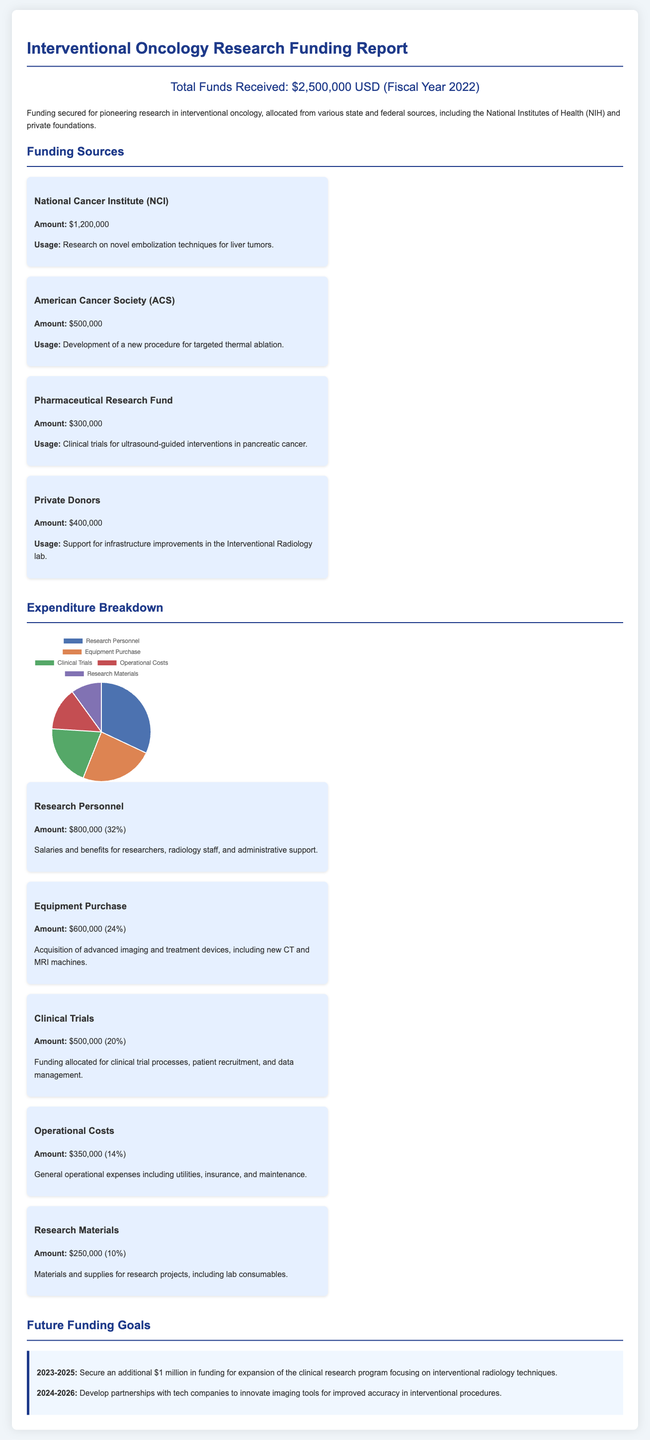What is the total funds received? The total funds received is stated clearly at the beginning of the report.
Answer: $2,500,000 What is the amount received from the National Cancer Institute? The report provides the amount received from each funding source, including the National Cancer Institute.
Answer: $1,200,000 What is the primary usage of the funds allocated by the American Cancer Society? The report outlines the specific usage of the funds allocated by each source, highlighting the American Cancer Society's focus.
Answer: Development of a new procedure for targeted thermal ablation How much of the total funding is allocated for clinical trials? The document includes a breakdown of expenditures, detailing the amount specifically for clinical trials.
Answer: $500,000 What percentage of the funding was spent on equipment purchase? The expenditure breakdown includes percentages alongside amounts, allowing for an easy calculation based on the provided figures.
Answer: 24% Which source provided the least amount of funding? Analyzing the funding sources, the one with the least contribution can be identified from the amounts listed.
Answer: Pharmaceutical Research Fund What is the future funding goal for 2023-2025? The document states future goals explicitly with timelines and intended amounts for funding acquisition.
Answer: $1 million What portion of the funds was used for operational costs? The detailed expenditure section includes categorization, allowing for quick identification of amounts allocated for operational costs.
Answer: $350,000 How many main funding sources are listed in the report? The report enumerates the funding sources, allowing for a count based on the distinct categories mentioned.
Answer: Four 